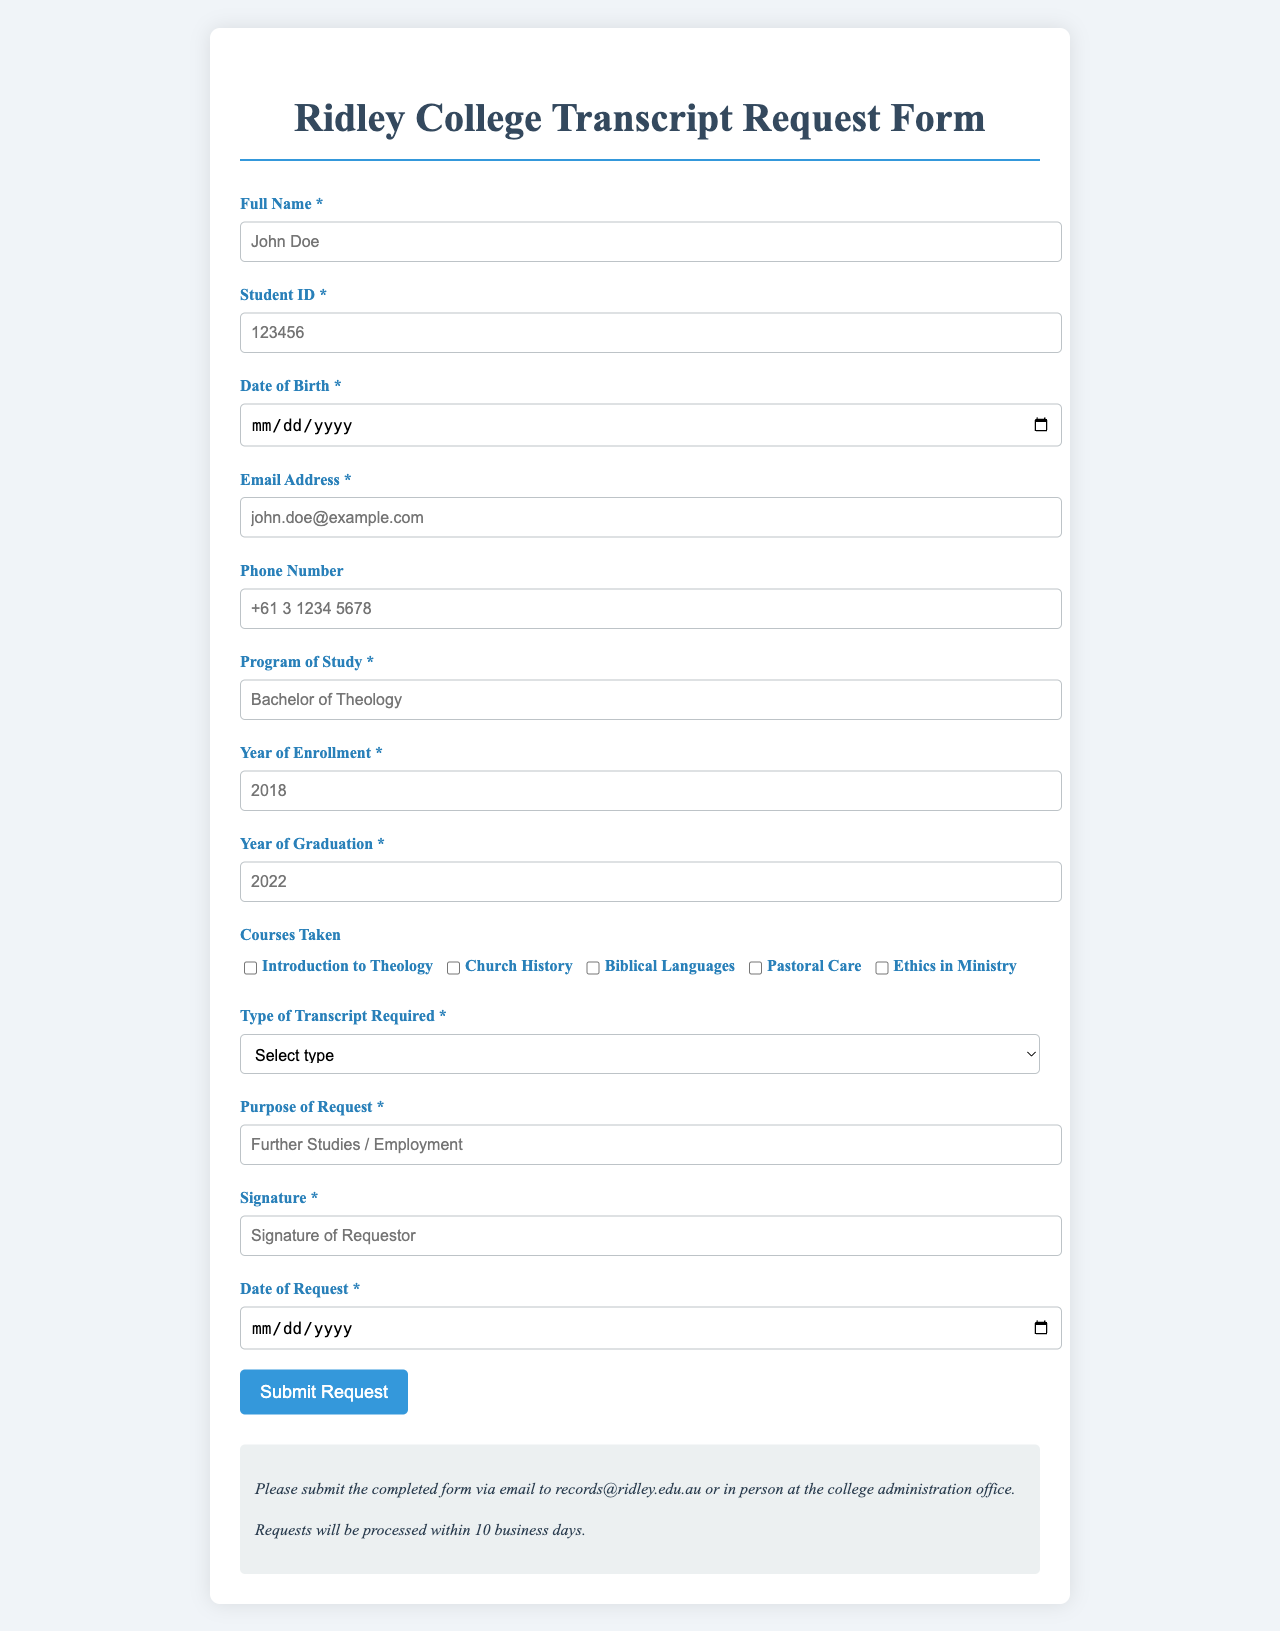What is the required document for transcript requests? The form specifies that either an Official Transcript or an Unofficial Transcript can be requested.
Answer: Official Transcript or Unofficial Transcript What is the email address to submit the completed form? The document states that completed forms should be submitted via email to the provided email address.
Answer: records@ridley.edu.au What is the purpose of this form? The form is used to request academic transcripts from Ridley College.
Answer: Request academic transcripts What information must be provided for the date of birth? The required input field in the form states that the date of birth must be provided.
Answer: Required How many courses can be selected for the transcript request? The document lists five specific courses that can be selected through checkboxes.
Answer: Five What should be included in the "Purpose of Request" section? The form allows the requestor to input their specific purpose for the transcript, like further studies or employment.
Answer: Further Studies / Employment What should the signature represent in the form? The signature required on the form is meant to confirm the requestor's identity and approval of the request.
Answer: Signature of Requestor How long will it take for the request to be processed? The document mentions that requests will be processed within a specific timeframe.
Answer: 10 business days What is the required program of study input in the form? The form requires the individual to enter their specific program of study.
Answer: Bachelor of Theology What is the placeholder text for the student ID field? The student ID field includes specific placeholder text to guide users on the data format needed.
Answer: 123456 